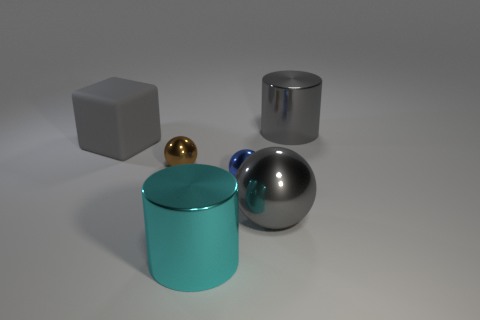Is there any indication of what the purpose of these objects might be? Without additional context, determining a specific purpose is challenging. However, these objects could be used for instructional purposes, such as demonstrating the properties of light and reflections on different materials in a controlled setting. 